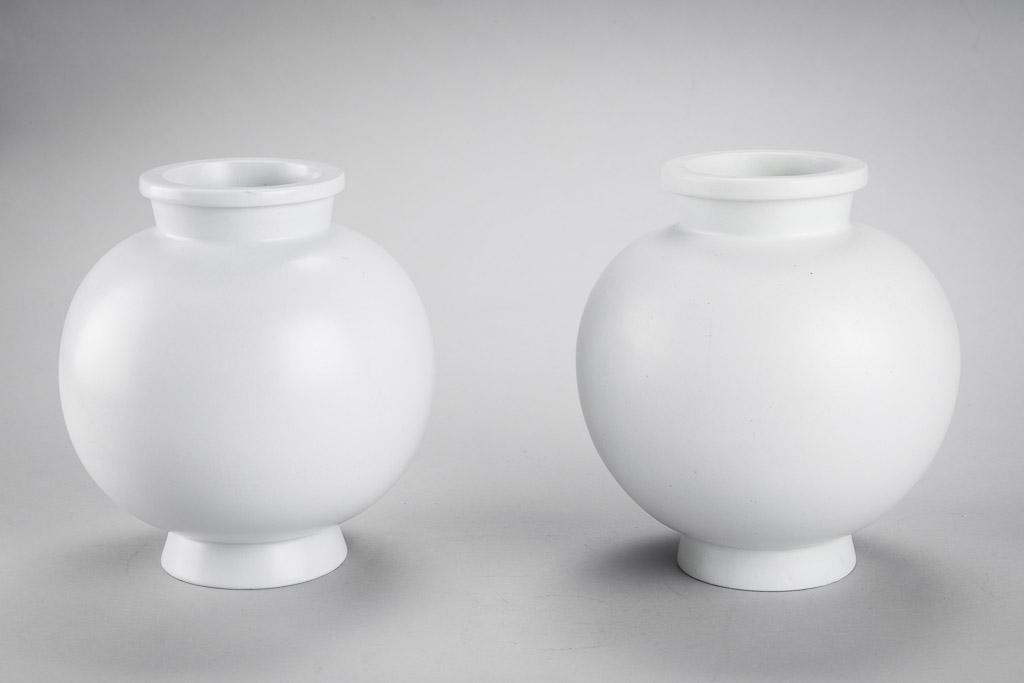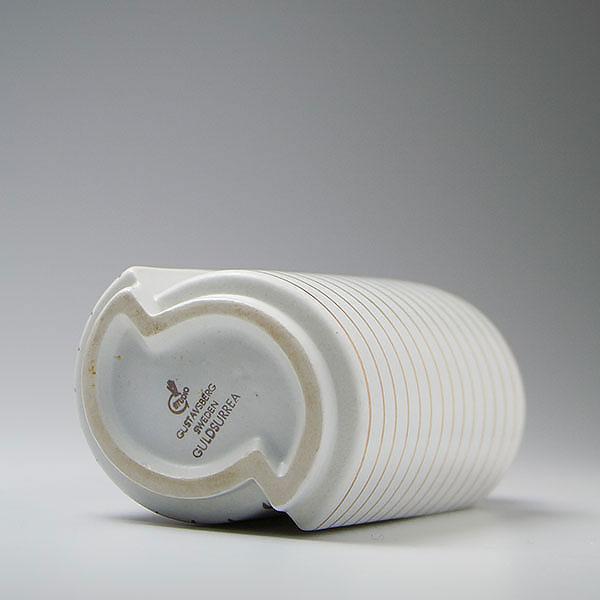The first image is the image on the left, the second image is the image on the right. Assess this claim about the two images: "One image shows a neutral-colored vase with a base that is not round.". Correct or not? Answer yes or no. Yes. The first image is the image on the left, the second image is the image on the right. Examine the images to the left and right. Is the description "One image shows two vases that are similar in size with top openings that are smaller than the body of the vase, but that are different designs." accurate? Answer yes or no. No. 